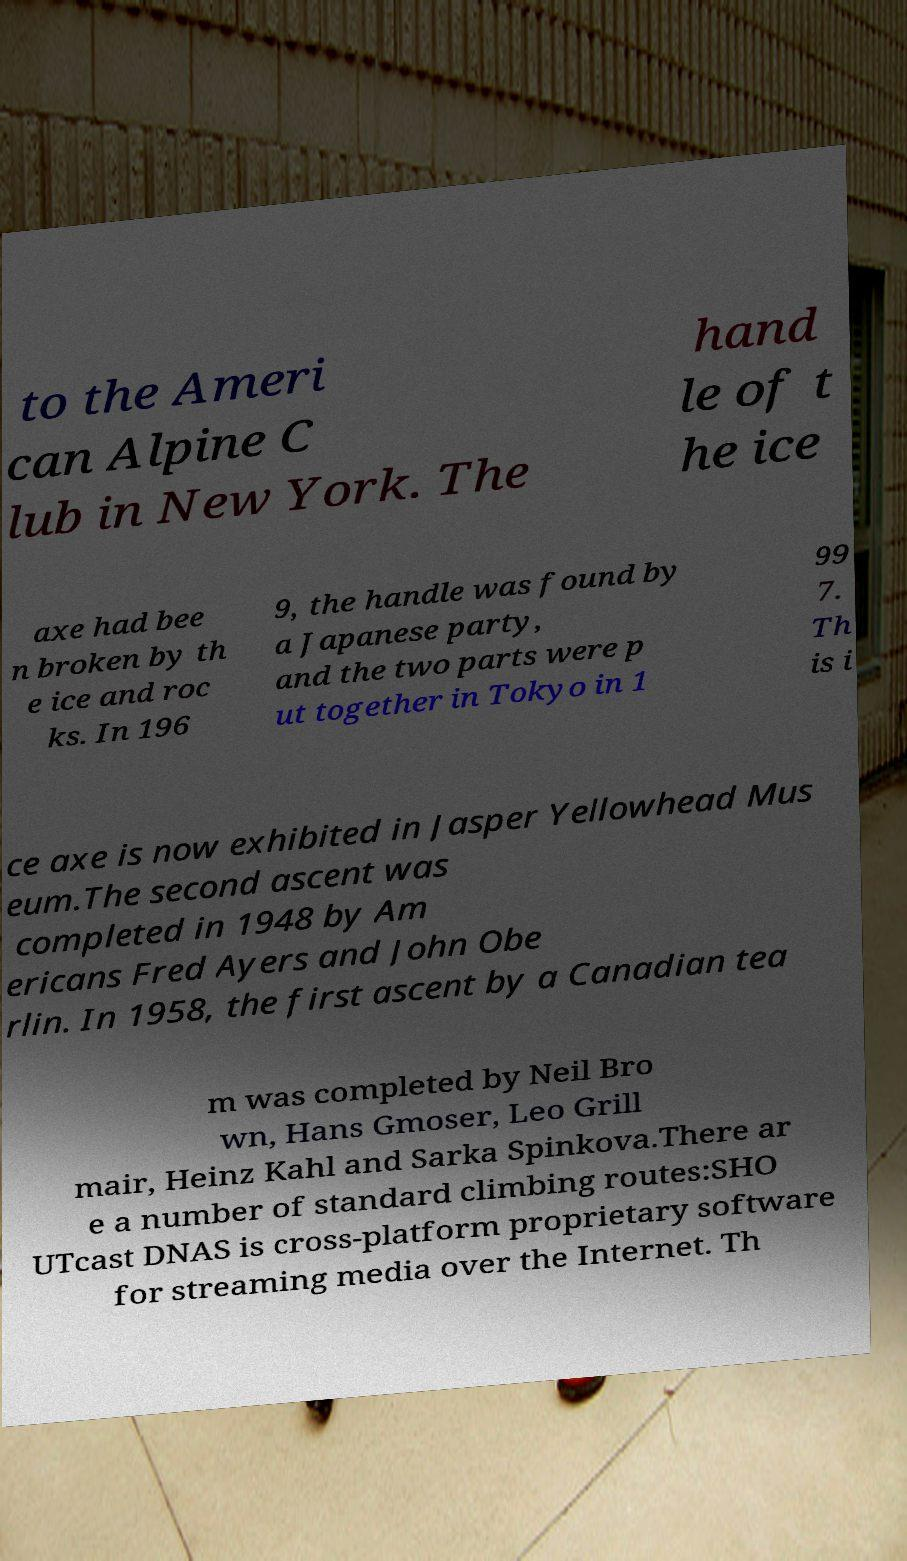Could you extract and type out the text from this image? to the Ameri can Alpine C lub in New York. The hand le of t he ice axe had bee n broken by th e ice and roc ks. In 196 9, the handle was found by a Japanese party, and the two parts were p ut together in Tokyo in 1 99 7. Th is i ce axe is now exhibited in Jasper Yellowhead Mus eum.The second ascent was completed in 1948 by Am ericans Fred Ayers and John Obe rlin. In 1958, the first ascent by a Canadian tea m was completed by Neil Bro wn, Hans Gmoser, Leo Grill mair, Heinz Kahl and Sarka Spinkova.There ar e a number of standard climbing routes:SHO UTcast DNAS is cross-platform proprietary software for streaming media over the Internet. Th 